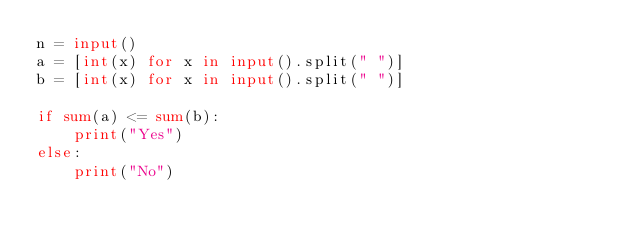<code> <loc_0><loc_0><loc_500><loc_500><_Python_>n = input()
a = [int(x) for x in input().split(" ")]
b = [int(x) for x in input().split(" ")]

if sum(a) <= sum(b):
    print("Yes")
else:
    print("No")
</code> 